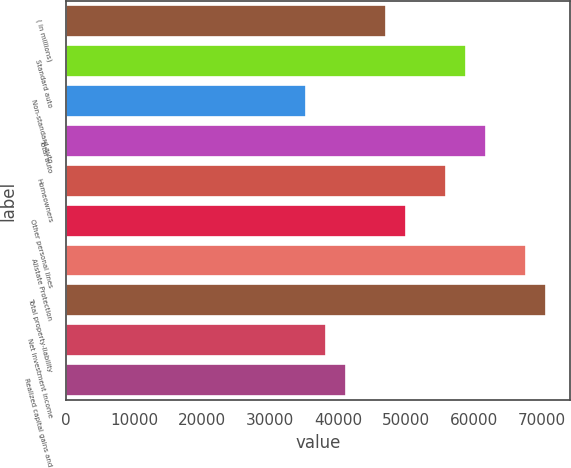Convert chart. <chart><loc_0><loc_0><loc_500><loc_500><bar_chart><fcel>( in millions)<fcel>Standard auto<fcel>Non-standard auto<fcel>Total auto<fcel>Homeowners<fcel>Other personal lines<fcel>Allstate Protection<fcel>Total property-liability<fcel>Net investment income<fcel>Realized capital gains and<nl><fcel>47029.8<fcel>58787<fcel>35272.6<fcel>61726.3<fcel>55847.7<fcel>49969.1<fcel>67604.9<fcel>70544.2<fcel>38211.9<fcel>41151.2<nl></chart> 